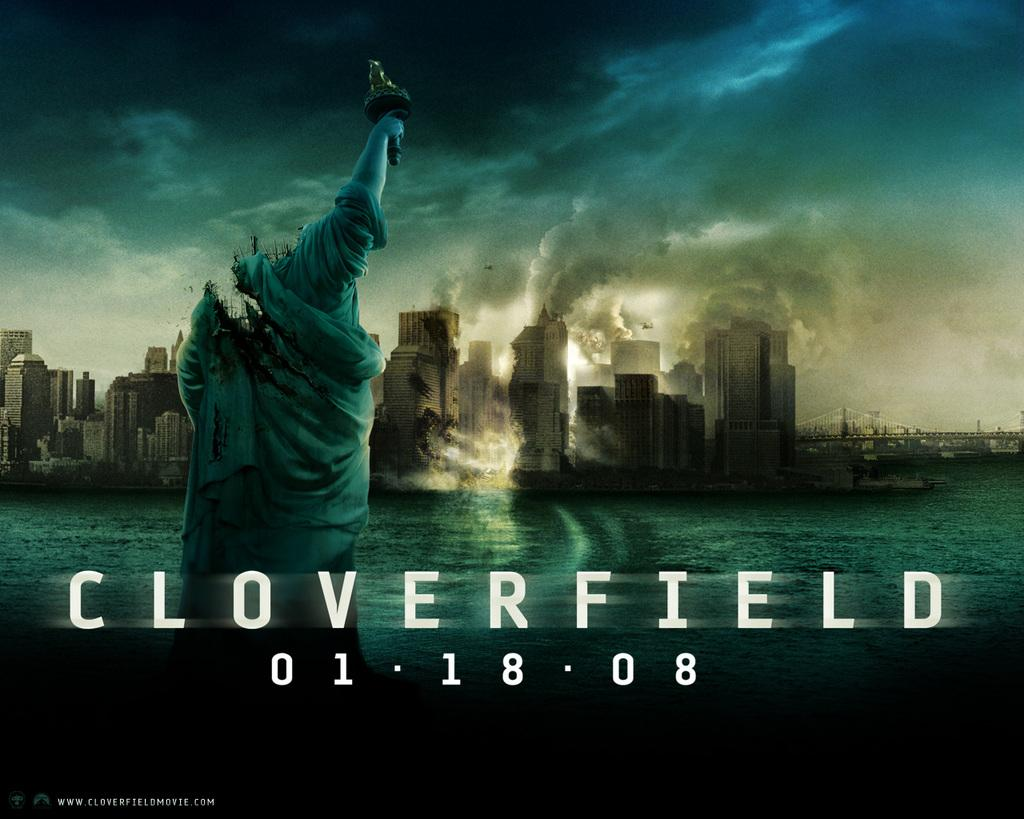Provide a one-sentence caption for the provided image. A movie poster for the movie Cloverfield shows the statue of Liberty destroyed. 